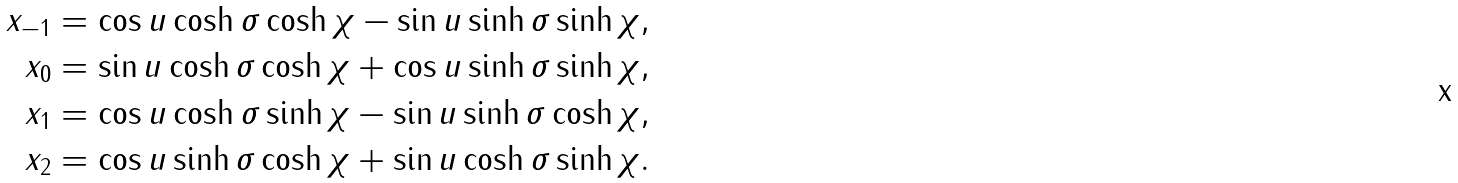Convert formula to latex. <formula><loc_0><loc_0><loc_500><loc_500>x _ { - 1 } & = \cos u \cosh \sigma \cosh \chi - \sin u \sinh \sigma \sinh \chi , \\ x _ { 0 } & = \sin u \cosh \sigma \cosh \chi + \cos u \sinh \sigma \sinh \chi , \\ x _ { 1 } & = \cos u \cosh \sigma \sinh \chi - \sin u \sinh \sigma \cosh \chi , \\ x _ { 2 } & = \cos u \sinh \sigma \cosh \chi + \sin u \cosh \sigma \sinh \chi .</formula> 